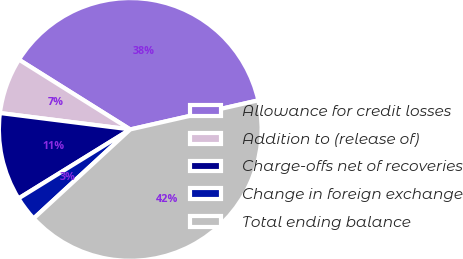Convert chart. <chart><loc_0><loc_0><loc_500><loc_500><pie_chart><fcel>Allowance for credit losses<fcel>Addition to (release of)<fcel>Charge-offs net of recoveries<fcel>Change in foreign exchange<fcel>Total ending balance<nl><fcel>37.53%<fcel>6.92%<fcel>10.8%<fcel>3.04%<fcel>41.7%<nl></chart> 